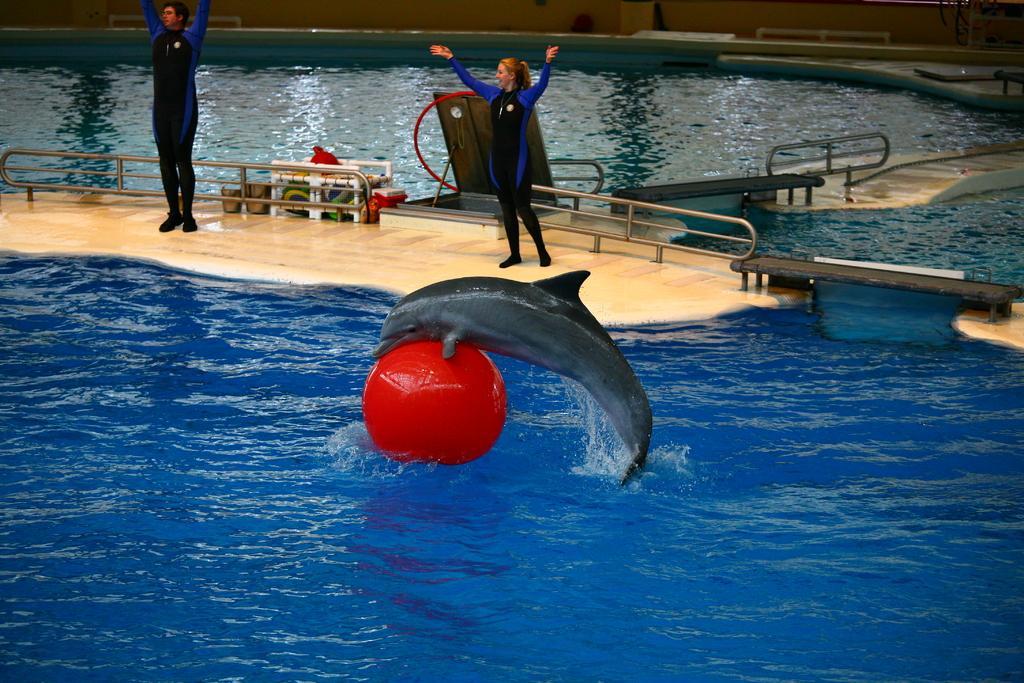Could you give a brief overview of what you see in this image? In this picture I can see the dolphin. I can see the red ball on the water. I can see two people standing on the surface. I can see railings. 